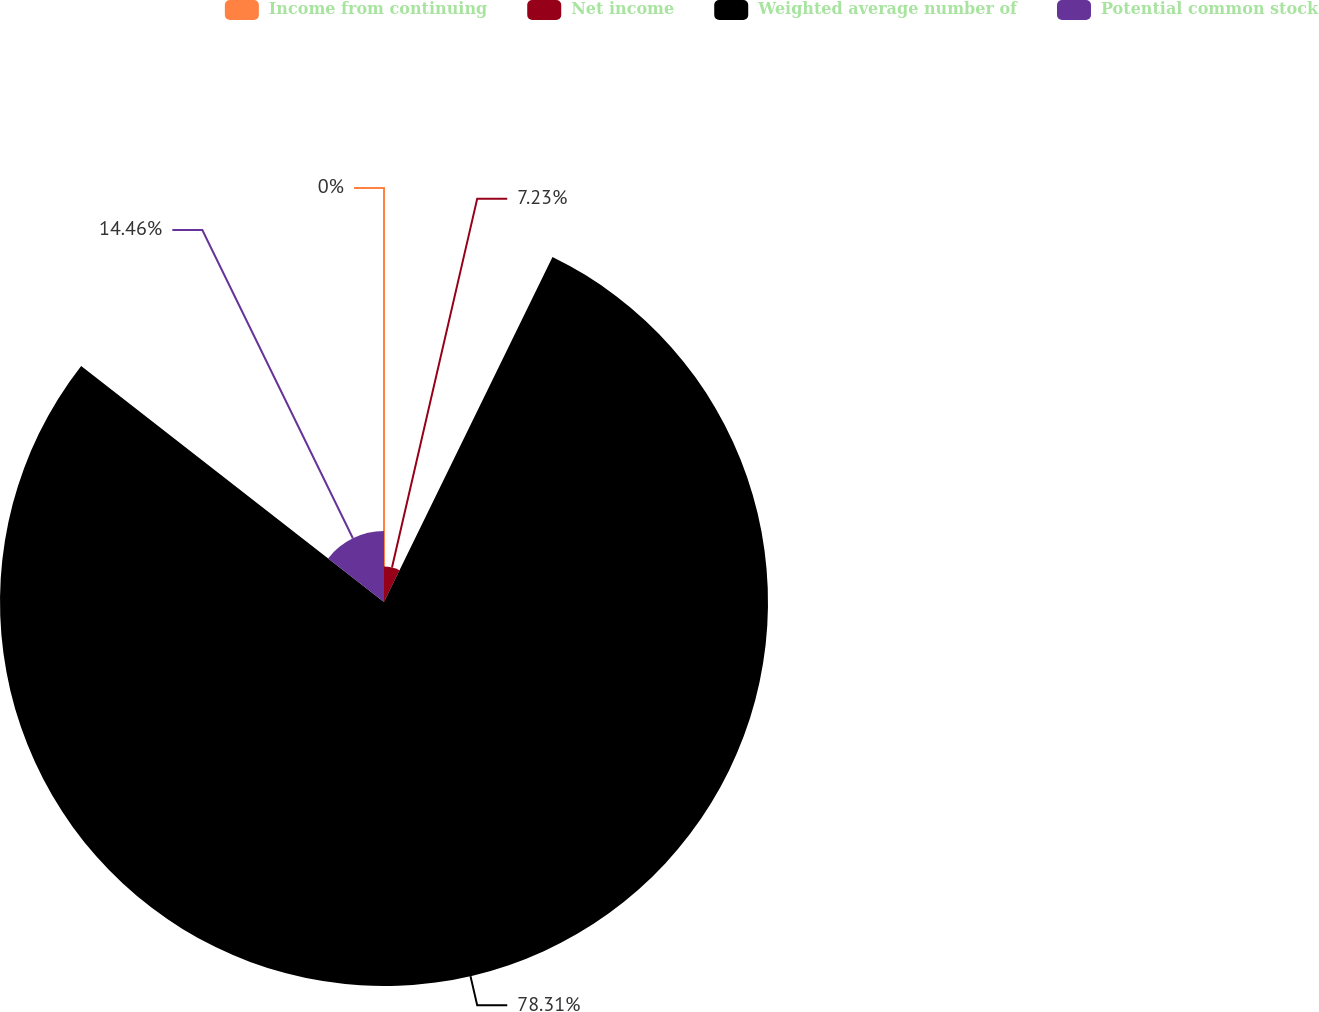Convert chart. <chart><loc_0><loc_0><loc_500><loc_500><pie_chart><fcel>Income from continuing<fcel>Net income<fcel>Weighted average number of<fcel>Potential common stock<nl><fcel>0.0%<fcel>7.23%<fcel>78.31%<fcel>14.46%<nl></chart> 